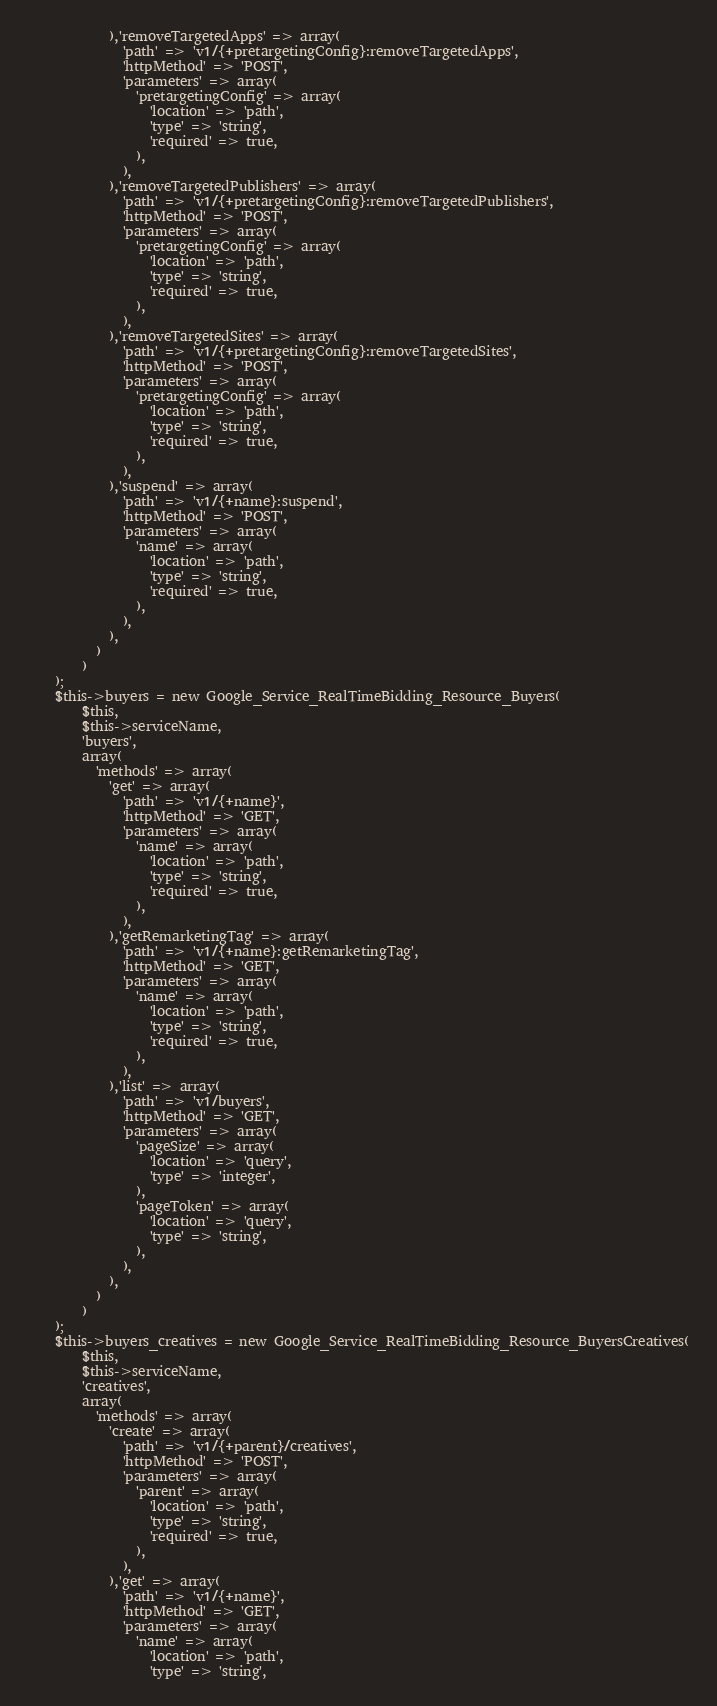Convert code to text. <code><loc_0><loc_0><loc_500><loc_500><_PHP_>            ),'removeTargetedApps' => array(
              'path' => 'v1/{+pretargetingConfig}:removeTargetedApps',
              'httpMethod' => 'POST',
              'parameters' => array(
                'pretargetingConfig' => array(
                  'location' => 'path',
                  'type' => 'string',
                  'required' => true,
                ),
              ),
            ),'removeTargetedPublishers' => array(
              'path' => 'v1/{+pretargetingConfig}:removeTargetedPublishers',
              'httpMethod' => 'POST',
              'parameters' => array(
                'pretargetingConfig' => array(
                  'location' => 'path',
                  'type' => 'string',
                  'required' => true,
                ),
              ),
            ),'removeTargetedSites' => array(
              'path' => 'v1/{+pretargetingConfig}:removeTargetedSites',
              'httpMethod' => 'POST',
              'parameters' => array(
                'pretargetingConfig' => array(
                  'location' => 'path',
                  'type' => 'string',
                  'required' => true,
                ),
              ),
            ),'suspend' => array(
              'path' => 'v1/{+name}:suspend',
              'httpMethod' => 'POST',
              'parameters' => array(
                'name' => array(
                  'location' => 'path',
                  'type' => 'string',
                  'required' => true,
                ),
              ),
            ),
          )
        )
    );
    $this->buyers = new Google_Service_RealTimeBidding_Resource_Buyers(
        $this,
        $this->serviceName,
        'buyers',
        array(
          'methods' => array(
            'get' => array(
              'path' => 'v1/{+name}',
              'httpMethod' => 'GET',
              'parameters' => array(
                'name' => array(
                  'location' => 'path',
                  'type' => 'string',
                  'required' => true,
                ),
              ),
            ),'getRemarketingTag' => array(
              'path' => 'v1/{+name}:getRemarketingTag',
              'httpMethod' => 'GET',
              'parameters' => array(
                'name' => array(
                  'location' => 'path',
                  'type' => 'string',
                  'required' => true,
                ),
              ),
            ),'list' => array(
              'path' => 'v1/buyers',
              'httpMethod' => 'GET',
              'parameters' => array(
                'pageSize' => array(
                  'location' => 'query',
                  'type' => 'integer',
                ),
                'pageToken' => array(
                  'location' => 'query',
                  'type' => 'string',
                ),
              ),
            ),
          )
        )
    );
    $this->buyers_creatives = new Google_Service_RealTimeBidding_Resource_BuyersCreatives(
        $this,
        $this->serviceName,
        'creatives',
        array(
          'methods' => array(
            'create' => array(
              'path' => 'v1/{+parent}/creatives',
              'httpMethod' => 'POST',
              'parameters' => array(
                'parent' => array(
                  'location' => 'path',
                  'type' => 'string',
                  'required' => true,
                ),
              ),
            ),'get' => array(
              'path' => 'v1/{+name}',
              'httpMethod' => 'GET',
              'parameters' => array(
                'name' => array(
                  'location' => 'path',
                  'type' => 'string',</code> 